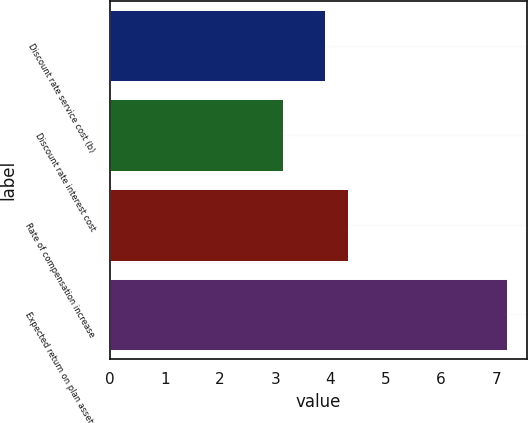Convert chart to OTSL. <chart><loc_0><loc_0><loc_500><loc_500><bar_chart><fcel>Discount rate service cost (b)<fcel>Discount rate interest cost<fcel>Rate of compensation increase<fcel>Expected return on plan assets<nl><fcel>3.9<fcel>3.14<fcel>4.31<fcel>7.2<nl></chart> 